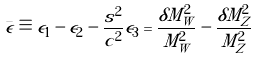<formula> <loc_0><loc_0><loc_500><loc_500>\bar { \epsilon } \equiv \epsilon _ { 1 } - \epsilon _ { 2 } - \frac { s ^ { 2 } } { c ^ { 2 } } \epsilon _ { 3 } = \frac { \delta M _ { W } ^ { 2 } } { M _ { W } ^ { 2 } } - \frac { \delta M _ { Z } ^ { 2 } } { M _ { Z } ^ { 2 } }</formula> 